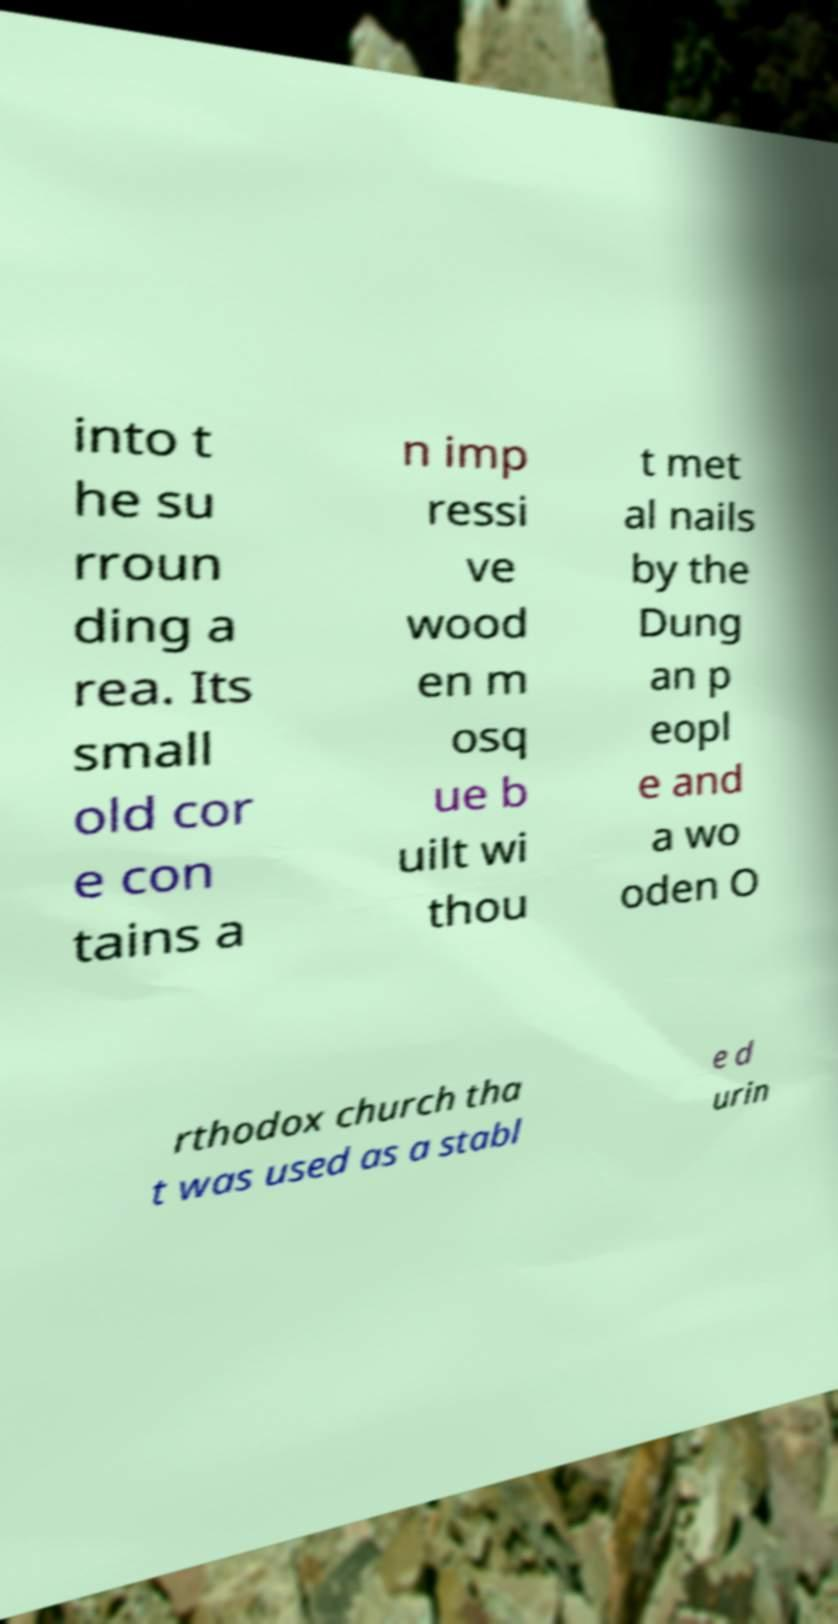What messages or text are displayed in this image? I need them in a readable, typed format. into t he su rroun ding a rea. Its small old cor e con tains a n imp ressi ve wood en m osq ue b uilt wi thou t met al nails by the Dung an p eopl e and a wo oden O rthodox church tha t was used as a stabl e d urin 